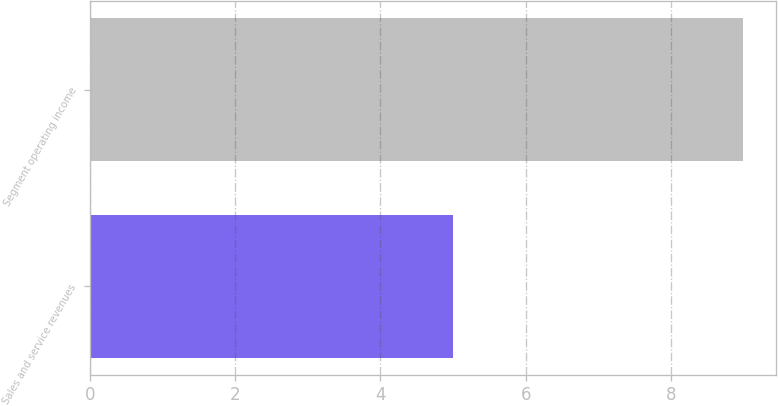Convert chart to OTSL. <chart><loc_0><loc_0><loc_500><loc_500><bar_chart><fcel>Sales and service revenues<fcel>Segment operating income<nl><fcel>5<fcel>9<nl></chart> 